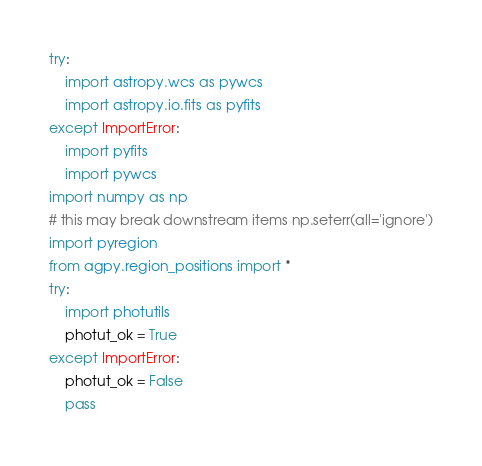Convert code to text. <code><loc_0><loc_0><loc_500><loc_500><_Python_>try:
    import astropy.wcs as pywcs
    import astropy.io.fits as pyfits
except ImportError:
    import pyfits
    import pywcs
import numpy as np
# this may break downstream items np.seterr(all='ignore')
import pyregion
from agpy.region_positions import *
try:
    import photutils
    photut_ok = True
except ImportError:
    photut_ok = False
    pass
</code> 